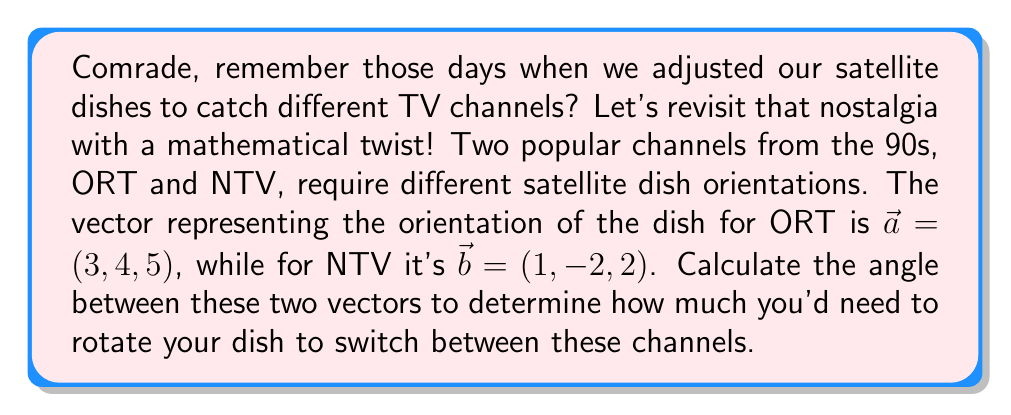Help me with this question. To find the angle between two vectors, we'll use the dot product formula:

$$\cos \theta = \frac{\vec{a} \cdot \vec{b}}{|\vec{a}||\vec{b}|}$$

Let's break this down step-by-step:

1) First, calculate the dot product $\vec{a} \cdot \vec{b}$:
   $$\vec{a} \cdot \vec{b} = (3)(1) + (4)(-2) + (5)(2) = 3 - 8 + 10 = 5$$

2) Next, calculate the magnitudes of the vectors:
   $$|\vec{a}| = \sqrt{3^2 + 4^2 + 5^2} = \sqrt{9 + 16 + 25} = \sqrt{50}$$
   $$|\vec{b}| = \sqrt{1^2 + (-2)^2 + 2^2} = \sqrt{1 + 4 + 4} = 3$$

3) Now, substitute these values into the formula:
   $$\cos \theta = \frac{5}{\sqrt{50} \cdot 3}$$

4) Simplify:
   $$\cos \theta = \frac{5}{3\sqrt{50}} = \frac{5}{3\sqrt{2} \cdot 5} = \frac{1}{3\sqrt{2}}$$

5) To get the angle, we need to take the inverse cosine (arccos) of both sides:
   $$\theta = \arccos(\frac{1}{3\sqrt{2}})$$

6) Using a calculator or computer, we can evaluate this:
   $$\theta \approx 1.249 \text{ radians}$$

7) Convert to degrees:
   $$\theta \approx 1.249 \cdot \frac{180}{\pi} \approx 71.57°$$
Answer: The angle between the two vectors is approximately 71.57°. 